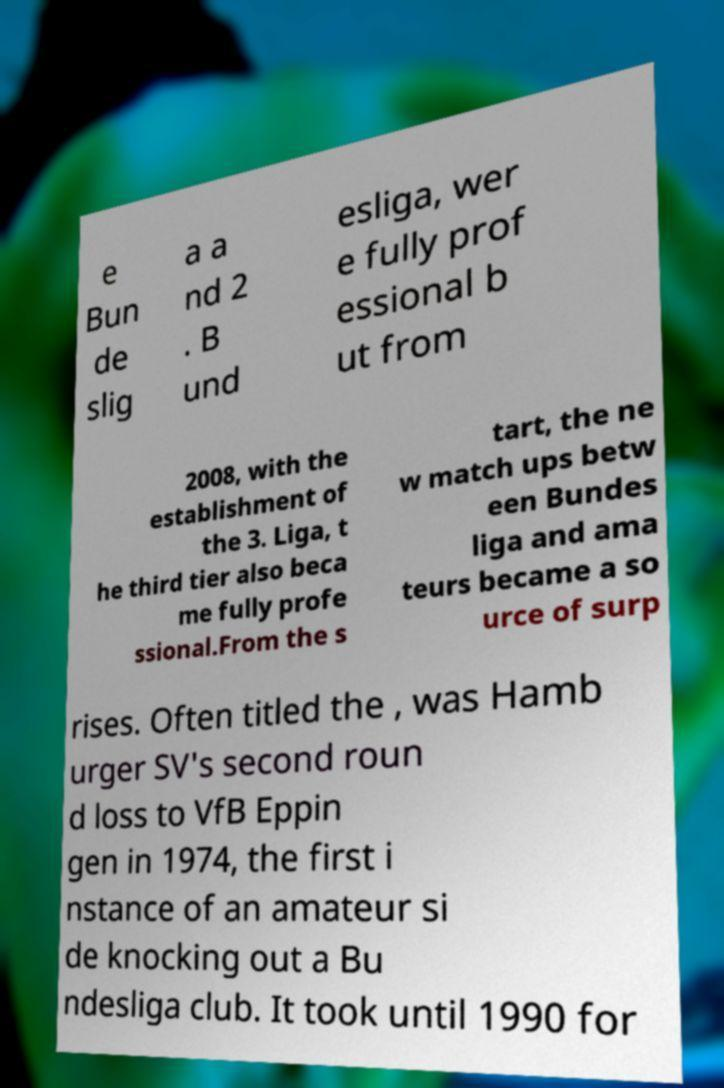Could you assist in decoding the text presented in this image and type it out clearly? e Bun de slig a a nd 2 . B und esliga, wer e fully prof essional b ut from 2008, with the establishment of the 3. Liga, t he third tier also beca me fully profe ssional.From the s tart, the ne w match ups betw een Bundes liga and ama teurs became a so urce of surp rises. Often titled the , was Hamb urger SV's second roun d loss to VfB Eppin gen in 1974, the first i nstance of an amateur si de knocking out a Bu ndesliga club. It took until 1990 for 